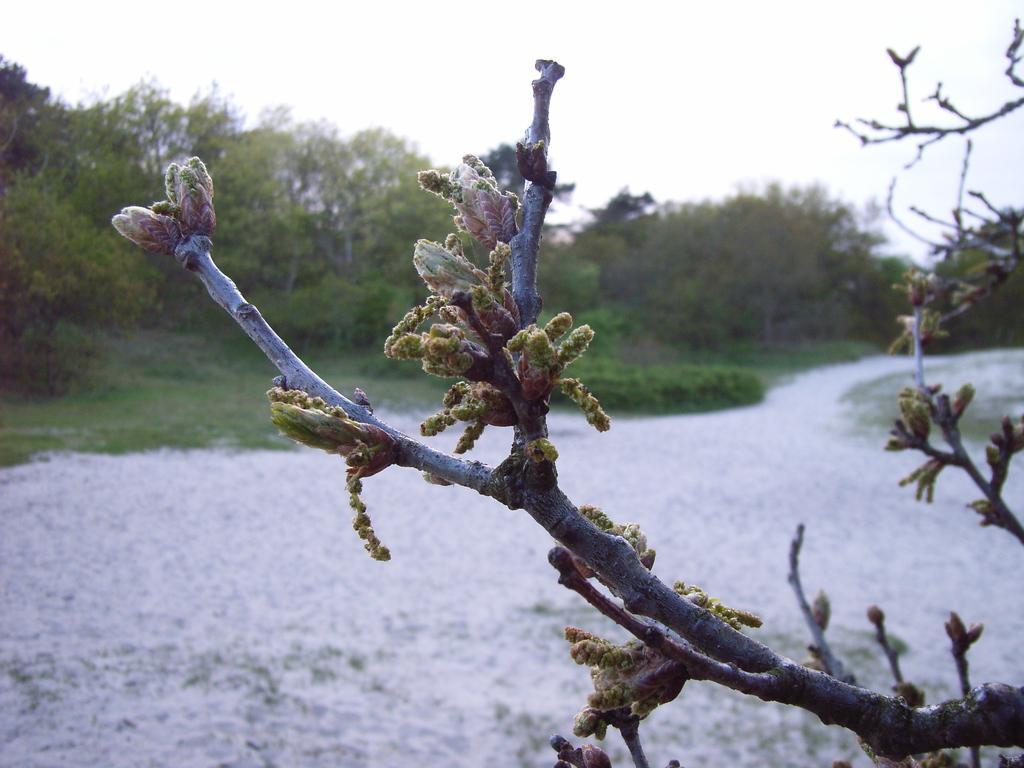In one or two sentences, can you explain what this image depicts? In this image I can see the plant and there are few buds to it. To the left I can see many trees. And in the back I can see the white sky. 